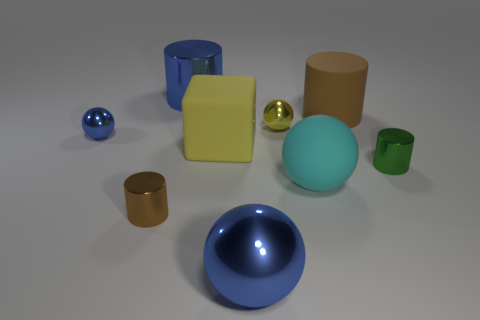How many shiny things are either large cubes or yellow balls?
Your answer should be compact. 1. What number of shiny objects are the same color as the cube?
Provide a short and direct response. 1. There is a brown cylinder that is in front of the brown cylinder behind the tiny green thing; what is it made of?
Your answer should be compact. Metal. What size is the yellow metallic thing?
Offer a terse response. Small. What number of metal blocks have the same size as the blue metallic cylinder?
Make the answer very short. 0. What number of small yellow objects are the same shape as the small green thing?
Ensure brevity in your answer.  0. Are there an equal number of large cylinders that are in front of the green shiny cylinder and tiny purple spheres?
Your answer should be compact. Yes. Are there any other things that are the same size as the green thing?
Provide a short and direct response. Yes. What shape is the yellow matte thing that is the same size as the brown rubber cylinder?
Ensure brevity in your answer.  Cube. Is there a tiny yellow thing that has the same shape as the big yellow thing?
Offer a very short reply. No. 